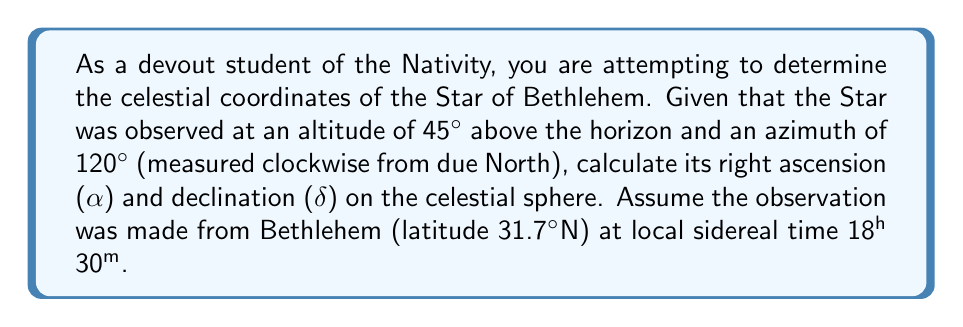Can you solve this math problem? To solve this problem, we need to convert from the horizontal coordinate system (altitude and azimuth) to the equatorial coordinate system (right ascension and declination). We'll use the following steps:

1. Convert altitude (a) and azimuth (A) to hour angle (H) and declination (δ):

   $$\sin(\delta) = \sin(\phi)\sin(a) + \cos(\phi)\cos(a)\cos(A)$$
   $$\cos(H) = \frac{\sin(a) - \sin(\phi)\sin(\delta)}{\cos(\phi)\cos(\delta)}$$

   Where φ is the observer's latitude.

2. Calculate the right ascension (α) using the hour angle (H) and local sidereal time (LST):

   $$\alpha = LST - H$$

Let's apply these formulas:

Step 1: Calculate declination (δ)
$$\sin(\delta) = \sin(31.7°)\sin(45°) + \cos(31.7°)\cos(45°)\cos(120°)$$
$$\delta = \arcsin(0.3660) = 21.5°$$

Step 2: Calculate hour angle (H)
$$\cos(H) = \frac{\sin(45°) - \sin(31.7°)\sin(21.5°)}{\cos(31.7°)\cos(21.5°)}$$
$$H = \arccos(0.1373) = 82.1°$$

Convert H to hours: $82.1° \times \frac{24h}{360°} = 5h 29m$

Step 3: Calculate right ascension (α)
$$\alpha = LST - H$$
$$\alpha = 18h 30m - 5h 29m = 13h 1m$$

Therefore, the celestial coordinates of the Star of Bethlehem are:
Right Ascension (α) = 13h 1m
Declination (δ) = 21.5°
Answer: Right Ascension (α) = 13h 1m, Declination (δ) = 21.5° 